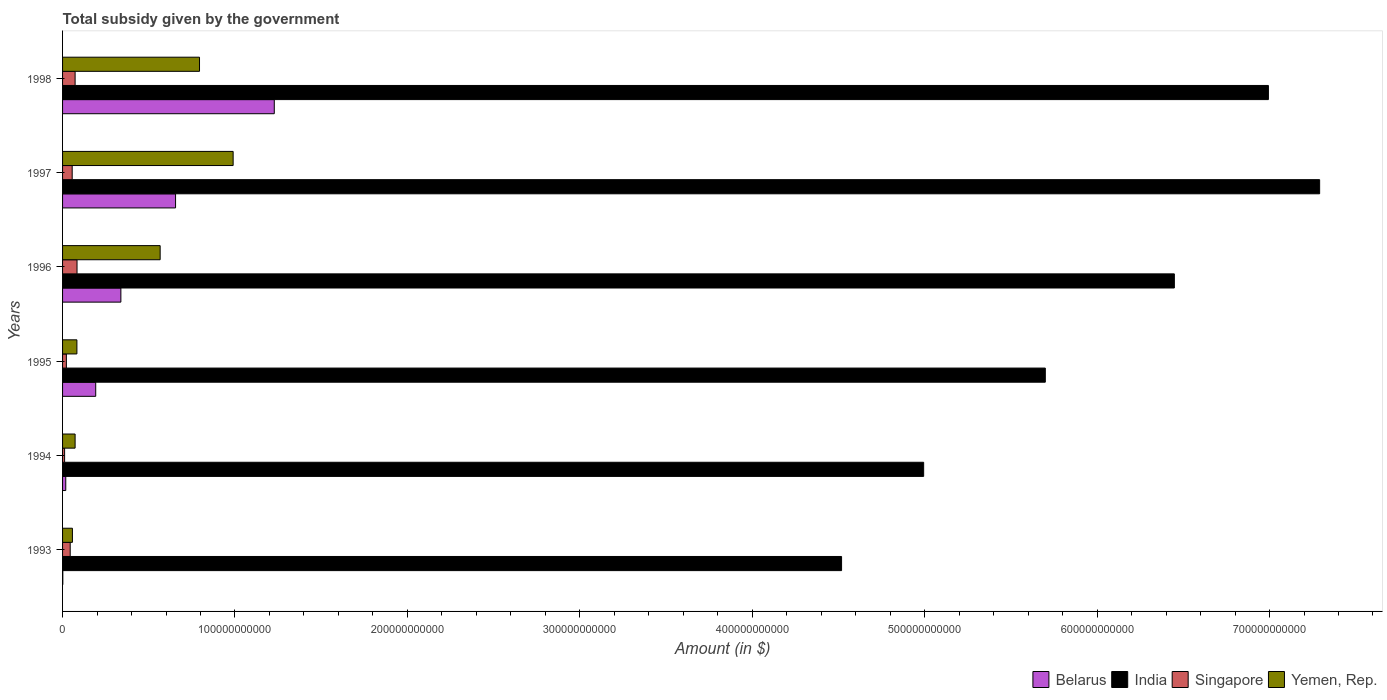How many different coloured bars are there?
Your response must be concise. 4. How many groups of bars are there?
Offer a terse response. 6. Are the number of bars on each tick of the Y-axis equal?
Make the answer very short. Yes. How many bars are there on the 5th tick from the bottom?
Keep it short and to the point. 4. What is the label of the 3rd group of bars from the top?
Provide a succinct answer. 1996. In how many cases, is the number of bars for a given year not equal to the number of legend labels?
Provide a short and direct response. 0. What is the total revenue collected by the government in India in 1994?
Keep it short and to the point. 4.99e+11. Across all years, what is the maximum total revenue collected by the government in Singapore?
Offer a terse response. 8.39e+09. Across all years, what is the minimum total revenue collected by the government in Belarus?
Offer a very short reply. 1.42e+08. In which year was the total revenue collected by the government in Yemen, Rep. maximum?
Provide a succinct answer. 1997. What is the total total revenue collected by the government in Belarus in the graph?
Provide a succinct answer. 2.43e+11. What is the difference between the total revenue collected by the government in Belarus in 1993 and that in 1995?
Your answer should be compact. -1.91e+1. What is the difference between the total revenue collected by the government in Belarus in 1996 and the total revenue collected by the government in India in 1997?
Make the answer very short. -6.95e+11. What is the average total revenue collected by the government in India per year?
Your answer should be very brief. 5.99e+11. In the year 1993, what is the difference between the total revenue collected by the government in India and total revenue collected by the government in Belarus?
Your response must be concise. 4.52e+11. What is the ratio of the total revenue collected by the government in Yemen, Rep. in 1993 to that in 1996?
Ensure brevity in your answer.  0.1. Is the total revenue collected by the government in Belarus in 1993 less than that in 1996?
Keep it short and to the point. Yes. What is the difference between the highest and the second highest total revenue collected by the government in Belarus?
Ensure brevity in your answer.  5.73e+1. What is the difference between the highest and the lowest total revenue collected by the government in Singapore?
Provide a succinct answer. 7.20e+09. In how many years, is the total revenue collected by the government in Belarus greater than the average total revenue collected by the government in Belarus taken over all years?
Your answer should be very brief. 2. Is the sum of the total revenue collected by the government in Belarus in 1994 and 1998 greater than the maximum total revenue collected by the government in Yemen, Rep. across all years?
Your answer should be very brief. Yes. Is it the case that in every year, the sum of the total revenue collected by the government in Singapore and total revenue collected by the government in India is greater than the sum of total revenue collected by the government in Yemen, Rep. and total revenue collected by the government in Belarus?
Your response must be concise. Yes. What does the 1st bar from the top in 1995 represents?
Your answer should be very brief. Yemen, Rep. What does the 1st bar from the bottom in 1995 represents?
Provide a succinct answer. Belarus. Is it the case that in every year, the sum of the total revenue collected by the government in Singapore and total revenue collected by the government in Yemen, Rep. is greater than the total revenue collected by the government in India?
Make the answer very short. No. How many bars are there?
Provide a short and direct response. 24. What is the difference between two consecutive major ticks on the X-axis?
Provide a succinct answer. 1.00e+11. How many legend labels are there?
Provide a short and direct response. 4. How are the legend labels stacked?
Offer a very short reply. Horizontal. What is the title of the graph?
Ensure brevity in your answer.  Total subsidy given by the government. What is the label or title of the X-axis?
Your response must be concise. Amount (in $). What is the Amount (in $) in Belarus in 1993?
Make the answer very short. 1.42e+08. What is the Amount (in $) in India in 1993?
Provide a short and direct response. 4.52e+11. What is the Amount (in $) in Singapore in 1993?
Your answer should be compact. 4.43e+09. What is the Amount (in $) of Yemen, Rep. in 1993?
Provide a short and direct response. 5.71e+09. What is the Amount (in $) in Belarus in 1994?
Make the answer very short. 1.86e+09. What is the Amount (in $) in India in 1994?
Your answer should be compact. 4.99e+11. What is the Amount (in $) in Singapore in 1994?
Your answer should be very brief. 1.19e+09. What is the Amount (in $) of Yemen, Rep. in 1994?
Your answer should be compact. 7.27e+09. What is the Amount (in $) in Belarus in 1995?
Keep it short and to the point. 1.92e+1. What is the Amount (in $) of India in 1995?
Make the answer very short. 5.70e+11. What is the Amount (in $) in Singapore in 1995?
Ensure brevity in your answer.  2.21e+09. What is the Amount (in $) in Yemen, Rep. in 1995?
Offer a very short reply. 8.32e+09. What is the Amount (in $) in Belarus in 1996?
Offer a very short reply. 3.38e+1. What is the Amount (in $) of India in 1996?
Offer a terse response. 6.45e+11. What is the Amount (in $) of Singapore in 1996?
Your answer should be very brief. 8.39e+09. What is the Amount (in $) of Yemen, Rep. in 1996?
Offer a very short reply. 5.66e+1. What is the Amount (in $) of Belarus in 1997?
Keep it short and to the point. 6.55e+1. What is the Amount (in $) in India in 1997?
Make the answer very short. 7.29e+11. What is the Amount (in $) of Singapore in 1997?
Give a very brief answer. 5.58e+09. What is the Amount (in $) of Yemen, Rep. in 1997?
Give a very brief answer. 9.89e+1. What is the Amount (in $) of Belarus in 1998?
Your answer should be compact. 1.23e+11. What is the Amount (in $) of India in 1998?
Make the answer very short. 6.99e+11. What is the Amount (in $) in Singapore in 1998?
Your answer should be very brief. 7.28e+09. What is the Amount (in $) of Yemen, Rep. in 1998?
Offer a terse response. 7.94e+1. Across all years, what is the maximum Amount (in $) of Belarus?
Offer a very short reply. 1.23e+11. Across all years, what is the maximum Amount (in $) of India?
Your response must be concise. 7.29e+11. Across all years, what is the maximum Amount (in $) of Singapore?
Keep it short and to the point. 8.39e+09. Across all years, what is the maximum Amount (in $) in Yemen, Rep.?
Offer a terse response. 9.89e+1. Across all years, what is the minimum Amount (in $) in Belarus?
Your answer should be very brief. 1.42e+08. Across all years, what is the minimum Amount (in $) of India?
Provide a short and direct response. 4.52e+11. Across all years, what is the minimum Amount (in $) of Singapore?
Provide a short and direct response. 1.19e+09. Across all years, what is the minimum Amount (in $) in Yemen, Rep.?
Provide a succinct answer. 5.71e+09. What is the total Amount (in $) of Belarus in the graph?
Your answer should be compact. 2.43e+11. What is the total Amount (in $) in India in the graph?
Your response must be concise. 3.59e+12. What is the total Amount (in $) in Singapore in the graph?
Provide a succinct answer. 2.91e+1. What is the total Amount (in $) in Yemen, Rep. in the graph?
Your response must be concise. 2.56e+11. What is the difference between the Amount (in $) in Belarus in 1993 and that in 1994?
Give a very brief answer. -1.72e+09. What is the difference between the Amount (in $) of India in 1993 and that in 1994?
Your answer should be very brief. -4.76e+1. What is the difference between the Amount (in $) in Singapore in 1993 and that in 1994?
Offer a terse response. 3.24e+09. What is the difference between the Amount (in $) of Yemen, Rep. in 1993 and that in 1994?
Give a very brief answer. -1.56e+09. What is the difference between the Amount (in $) in Belarus in 1993 and that in 1995?
Your response must be concise. -1.91e+1. What is the difference between the Amount (in $) of India in 1993 and that in 1995?
Ensure brevity in your answer.  -1.18e+11. What is the difference between the Amount (in $) of Singapore in 1993 and that in 1995?
Offer a very short reply. 2.22e+09. What is the difference between the Amount (in $) in Yemen, Rep. in 1993 and that in 1995?
Provide a short and direct response. -2.60e+09. What is the difference between the Amount (in $) in Belarus in 1993 and that in 1996?
Ensure brevity in your answer.  -3.37e+1. What is the difference between the Amount (in $) in India in 1993 and that in 1996?
Your answer should be compact. -1.93e+11. What is the difference between the Amount (in $) in Singapore in 1993 and that in 1996?
Ensure brevity in your answer.  -3.95e+09. What is the difference between the Amount (in $) in Yemen, Rep. in 1993 and that in 1996?
Provide a succinct answer. -5.09e+1. What is the difference between the Amount (in $) in Belarus in 1993 and that in 1997?
Ensure brevity in your answer.  -6.54e+1. What is the difference between the Amount (in $) in India in 1993 and that in 1997?
Your answer should be very brief. -2.77e+11. What is the difference between the Amount (in $) in Singapore in 1993 and that in 1997?
Make the answer very short. -1.15e+09. What is the difference between the Amount (in $) in Yemen, Rep. in 1993 and that in 1997?
Make the answer very short. -9.32e+1. What is the difference between the Amount (in $) in Belarus in 1993 and that in 1998?
Provide a short and direct response. -1.23e+11. What is the difference between the Amount (in $) of India in 1993 and that in 1998?
Your answer should be compact. -2.48e+11. What is the difference between the Amount (in $) in Singapore in 1993 and that in 1998?
Offer a very short reply. -2.84e+09. What is the difference between the Amount (in $) of Yemen, Rep. in 1993 and that in 1998?
Ensure brevity in your answer.  -7.37e+1. What is the difference between the Amount (in $) in Belarus in 1994 and that in 1995?
Your answer should be very brief. -1.74e+1. What is the difference between the Amount (in $) of India in 1994 and that in 1995?
Your answer should be compact. -7.06e+1. What is the difference between the Amount (in $) in Singapore in 1994 and that in 1995?
Your answer should be compact. -1.02e+09. What is the difference between the Amount (in $) in Yemen, Rep. in 1994 and that in 1995?
Provide a short and direct response. -1.04e+09. What is the difference between the Amount (in $) in Belarus in 1994 and that in 1996?
Make the answer very short. -3.20e+1. What is the difference between the Amount (in $) of India in 1994 and that in 1996?
Your answer should be compact. -1.45e+11. What is the difference between the Amount (in $) of Singapore in 1994 and that in 1996?
Offer a very short reply. -7.20e+09. What is the difference between the Amount (in $) in Yemen, Rep. in 1994 and that in 1996?
Provide a succinct answer. -4.93e+1. What is the difference between the Amount (in $) in Belarus in 1994 and that in 1997?
Your response must be concise. -6.37e+1. What is the difference between the Amount (in $) in India in 1994 and that in 1997?
Keep it short and to the point. -2.30e+11. What is the difference between the Amount (in $) of Singapore in 1994 and that in 1997?
Provide a short and direct response. -4.39e+09. What is the difference between the Amount (in $) in Yemen, Rep. in 1994 and that in 1997?
Make the answer very short. -9.17e+1. What is the difference between the Amount (in $) in Belarus in 1994 and that in 1998?
Provide a succinct answer. -1.21e+11. What is the difference between the Amount (in $) of India in 1994 and that in 1998?
Provide a succinct answer. -2.00e+11. What is the difference between the Amount (in $) of Singapore in 1994 and that in 1998?
Give a very brief answer. -6.09e+09. What is the difference between the Amount (in $) in Yemen, Rep. in 1994 and that in 1998?
Your answer should be compact. -7.22e+1. What is the difference between the Amount (in $) of Belarus in 1995 and that in 1996?
Make the answer very short. -1.46e+1. What is the difference between the Amount (in $) in India in 1995 and that in 1996?
Your answer should be compact. -7.48e+1. What is the difference between the Amount (in $) of Singapore in 1995 and that in 1996?
Give a very brief answer. -6.18e+09. What is the difference between the Amount (in $) in Yemen, Rep. in 1995 and that in 1996?
Offer a very short reply. -4.83e+1. What is the difference between the Amount (in $) in Belarus in 1995 and that in 1997?
Keep it short and to the point. -4.63e+1. What is the difference between the Amount (in $) in India in 1995 and that in 1997?
Make the answer very short. -1.59e+11. What is the difference between the Amount (in $) in Singapore in 1995 and that in 1997?
Provide a short and direct response. -3.37e+09. What is the difference between the Amount (in $) in Yemen, Rep. in 1995 and that in 1997?
Offer a very short reply. -9.06e+1. What is the difference between the Amount (in $) in Belarus in 1995 and that in 1998?
Make the answer very short. -1.04e+11. What is the difference between the Amount (in $) of India in 1995 and that in 1998?
Make the answer very short. -1.29e+11. What is the difference between the Amount (in $) of Singapore in 1995 and that in 1998?
Provide a succinct answer. -5.07e+09. What is the difference between the Amount (in $) in Yemen, Rep. in 1995 and that in 1998?
Keep it short and to the point. -7.11e+1. What is the difference between the Amount (in $) of Belarus in 1996 and that in 1997?
Provide a succinct answer. -3.17e+1. What is the difference between the Amount (in $) of India in 1996 and that in 1997?
Your answer should be very brief. -8.43e+1. What is the difference between the Amount (in $) of Singapore in 1996 and that in 1997?
Offer a very short reply. 2.80e+09. What is the difference between the Amount (in $) of Yemen, Rep. in 1996 and that in 1997?
Ensure brevity in your answer.  -4.23e+1. What is the difference between the Amount (in $) in Belarus in 1996 and that in 1998?
Provide a short and direct response. -8.90e+1. What is the difference between the Amount (in $) in India in 1996 and that in 1998?
Provide a short and direct response. -5.46e+1. What is the difference between the Amount (in $) in Singapore in 1996 and that in 1998?
Offer a terse response. 1.11e+09. What is the difference between the Amount (in $) of Yemen, Rep. in 1996 and that in 1998?
Offer a very short reply. -2.28e+1. What is the difference between the Amount (in $) in Belarus in 1997 and that in 1998?
Make the answer very short. -5.73e+1. What is the difference between the Amount (in $) of India in 1997 and that in 1998?
Give a very brief answer. 2.97e+1. What is the difference between the Amount (in $) of Singapore in 1997 and that in 1998?
Make the answer very short. -1.70e+09. What is the difference between the Amount (in $) of Yemen, Rep. in 1997 and that in 1998?
Give a very brief answer. 1.95e+1. What is the difference between the Amount (in $) in Belarus in 1993 and the Amount (in $) in India in 1994?
Your response must be concise. -4.99e+11. What is the difference between the Amount (in $) of Belarus in 1993 and the Amount (in $) of Singapore in 1994?
Make the answer very short. -1.05e+09. What is the difference between the Amount (in $) of Belarus in 1993 and the Amount (in $) of Yemen, Rep. in 1994?
Offer a very short reply. -7.13e+09. What is the difference between the Amount (in $) of India in 1993 and the Amount (in $) of Singapore in 1994?
Your answer should be very brief. 4.51e+11. What is the difference between the Amount (in $) in India in 1993 and the Amount (in $) in Yemen, Rep. in 1994?
Give a very brief answer. 4.45e+11. What is the difference between the Amount (in $) of Singapore in 1993 and the Amount (in $) of Yemen, Rep. in 1994?
Provide a succinct answer. -2.84e+09. What is the difference between the Amount (in $) of Belarus in 1993 and the Amount (in $) of India in 1995?
Offer a very short reply. -5.70e+11. What is the difference between the Amount (in $) in Belarus in 1993 and the Amount (in $) in Singapore in 1995?
Your answer should be very brief. -2.07e+09. What is the difference between the Amount (in $) of Belarus in 1993 and the Amount (in $) of Yemen, Rep. in 1995?
Offer a terse response. -8.17e+09. What is the difference between the Amount (in $) in India in 1993 and the Amount (in $) in Singapore in 1995?
Your answer should be compact. 4.50e+11. What is the difference between the Amount (in $) of India in 1993 and the Amount (in $) of Yemen, Rep. in 1995?
Offer a very short reply. 4.43e+11. What is the difference between the Amount (in $) of Singapore in 1993 and the Amount (in $) of Yemen, Rep. in 1995?
Ensure brevity in your answer.  -3.88e+09. What is the difference between the Amount (in $) in Belarus in 1993 and the Amount (in $) in India in 1996?
Keep it short and to the point. -6.45e+11. What is the difference between the Amount (in $) in Belarus in 1993 and the Amount (in $) in Singapore in 1996?
Your response must be concise. -8.24e+09. What is the difference between the Amount (in $) in Belarus in 1993 and the Amount (in $) in Yemen, Rep. in 1996?
Provide a short and direct response. -5.65e+1. What is the difference between the Amount (in $) in India in 1993 and the Amount (in $) in Singapore in 1996?
Keep it short and to the point. 4.43e+11. What is the difference between the Amount (in $) in India in 1993 and the Amount (in $) in Yemen, Rep. in 1996?
Provide a short and direct response. 3.95e+11. What is the difference between the Amount (in $) in Singapore in 1993 and the Amount (in $) in Yemen, Rep. in 1996?
Offer a very short reply. -5.22e+1. What is the difference between the Amount (in $) of Belarus in 1993 and the Amount (in $) of India in 1997?
Your answer should be compact. -7.29e+11. What is the difference between the Amount (in $) of Belarus in 1993 and the Amount (in $) of Singapore in 1997?
Provide a succinct answer. -5.44e+09. What is the difference between the Amount (in $) of Belarus in 1993 and the Amount (in $) of Yemen, Rep. in 1997?
Give a very brief answer. -9.88e+1. What is the difference between the Amount (in $) of India in 1993 and the Amount (in $) of Singapore in 1997?
Make the answer very short. 4.46e+11. What is the difference between the Amount (in $) of India in 1993 and the Amount (in $) of Yemen, Rep. in 1997?
Your answer should be very brief. 3.53e+11. What is the difference between the Amount (in $) of Singapore in 1993 and the Amount (in $) of Yemen, Rep. in 1997?
Give a very brief answer. -9.45e+1. What is the difference between the Amount (in $) in Belarus in 1993 and the Amount (in $) in India in 1998?
Offer a terse response. -6.99e+11. What is the difference between the Amount (in $) in Belarus in 1993 and the Amount (in $) in Singapore in 1998?
Your response must be concise. -7.14e+09. What is the difference between the Amount (in $) in Belarus in 1993 and the Amount (in $) in Yemen, Rep. in 1998?
Make the answer very short. -7.93e+1. What is the difference between the Amount (in $) of India in 1993 and the Amount (in $) of Singapore in 1998?
Make the answer very short. 4.45e+11. What is the difference between the Amount (in $) in India in 1993 and the Amount (in $) in Yemen, Rep. in 1998?
Make the answer very short. 3.72e+11. What is the difference between the Amount (in $) in Singapore in 1993 and the Amount (in $) in Yemen, Rep. in 1998?
Provide a succinct answer. -7.50e+1. What is the difference between the Amount (in $) in Belarus in 1994 and the Amount (in $) in India in 1995?
Keep it short and to the point. -5.68e+11. What is the difference between the Amount (in $) of Belarus in 1994 and the Amount (in $) of Singapore in 1995?
Your answer should be very brief. -3.52e+08. What is the difference between the Amount (in $) of Belarus in 1994 and the Amount (in $) of Yemen, Rep. in 1995?
Provide a succinct answer. -6.46e+09. What is the difference between the Amount (in $) in India in 1994 and the Amount (in $) in Singapore in 1995?
Provide a short and direct response. 4.97e+11. What is the difference between the Amount (in $) of India in 1994 and the Amount (in $) of Yemen, Rep. in 1995?
Your answer should be compact. 4.91e+11. What is the difference between the Amount (in $) of Singapore in 1994 and the Amount (in $) of Yemen, Rep. in 1995?
Your answer should be very brief. -7.13e+09. What is the difference between the Amount (in $) in Belarus in 1994 and the Amount (in $) in India in 1996?
Give a very brief answer. -6.43e+11. What is the difference between the Amount (in $) of Belarus in 1994 and the Amount (in $) of Singapore in 1996?
Offer a terse response. -6.53e+09. What is the difference between the Amount (in $) in Belarus in 1994 and the Amount (in $) in Yemen, Rep. in 1996?
Your answer should be compact. -5.47e+1. What is the difference between the Amount (in $) of India in 1994 and the Amount (in $) of Singapore in 1996?
Your response must be concise. 4.91e+11. What is the difference between the Amount (in $) in India in 1994 and the Amount (in $) in Yemen, Rep. in 1996?
Offer a very short reply. 4.43e+11. What is the difference between the Amount (in $) of Singapore in 1994 and the Amount (in $) of Yemen, Rep. in 1996?
Give a very brief answer. -5.54e+1. What is the difference between the Amount (in $) of Belarus in 1994 and the Amount (in $) of India in 1997?
Give a very brief answer. -7.27e+11. What is the difference between the Amount (in $) of Belarus in 1994 and the Amount (in $) of Singapore in 1997?
Give a very brief answer. -3.72e+09. What is the difference between the Amount (in $) of Belarus in 1994 and the Amount (in $) of Yemen, Rep. in 1997?
Provide a succinct answer. -9.71e+1. What is the difference between the Amount (in $) of India in 1994 and the Amount (in $) of Singapore in 1997?
Offer a very short reply. 4.94e+11. What is the difference between the Amount (in $) in India in 1994 and the Amount (in $) in Yemen, Rep. in 1997?
Offer a terse response. 4.00e+11. What is the difference between the Amount (in $) of Singapore in 1994 and the Amount (in $) of Yemen, Rep. in 1997?
Keep it short and to the point. -9.77e+1. What is the difference between the Amount (in $) of Belarus in 1994 and the Amount (in $) of India in 1998?
Offer a very short reply. -6.97e+11. What is the difference between the Amount (in $) in Belarus in 1994 and the Amount (in $) in Singapore in 1998?
Keep it short and to the point. -5.42e+09. What is the difference between the Amount (in $) in Belarus in 1994 and the Amount (in $) in Yemen, Rep. in 1998?
Provide a succinct answer. -7.76e+1. What is the difference between the Amount (in $) in India in 1994 and the Amount (in $) in Singapore in 1998?
Make the answer very short. 4.92e+11. What is the difference between the Amount (in $) of India in 1994 and the Amount (in $) of Yemen, Rep. in 1998?
Give a very brief answer. 4.20e+11. What is the difference between the Amount (in $) of Singapore in 1994 and the Amount (in $) of Yemen, Rep. in 1998?
Keep it short and to the point. -7.82e+1. What is the difference between the Amount (in $) of Belarus in 1995 and the Amount (in $) of India in 1996?
Your response must be concise. -6.26e+11. What is the difference between the Amount (in $) in Belarus in 1995 and the Amount (in $) in Singapore in 1996?
Offer a very short reply. 1.08e+1. What is the difference between the Amount (in $) of Belarus in 1995 and the Amount (in $) of Yemen, Rep. in 1996?
Ensure brevity in your answer.  -3.74e+1. What is the difference between the Amount (in $) of India in 1995 and the Amount (in $) of Singapore in 1996?
Provide a succinct answer. 5.62e+11. What is the difference between the Amount (in $) of India in 1995 and the Amount (in $) of Yemen, Rep. in 1996?
Give a very brief answer. 5.13e+11. What is the difference between the Amount (in $) of Singapore in 1995 and the Amount (in $) of Yemen, Rep. in 1996?
Offer a terse response. -5.44e+1. What is the difference between the Amount (in $) of Belarus in 1995 and the Amount (in $) of India in 1997?
Provide a short and direct response. -7.10e+11. What is the difference between the Amount (in $) in Belarus in 1995 and the Amount (in $) in Singapore in 1997?
Make the answer very short. 1.36e+1. What is the difference between the Amount (in $) in Belarus in 1995 and the Amount (in $) in Yemen, Rep. in 1997?
Keep it short and to the point. -7.97e+1. What is the difference between the Amount (in $) in India in 1995 and the Amount (in $) in Singapore in 1997?
Give a very brief answer. 5.64e+11. What is the difference between the Amount (in $) of India in 1995 and the Amount (in $) of Yemen, Rep. in 1997?
Keep it short and to the point. 4.71e+11. What is the difference between the Amount (in $) of Singapore in 1995 and the Amount (in $) of Yemen, Rep. in 1997?
Your answer should be very brief. -9.67e+1. What is the difference between the Amount (in $) in Belarus in 1995 and the Amount (in $) in India in 1998?
Your response must be concise. -6.80e+11. What is the difference between the Amount (in $) in Belarus in 1995 and the Amount (in $) in Singapore in 1998?
Provide a succinct answer. 1.19e+1. What is the difference between the Amount (in $) in Belarus in 1995 and the Amount (in $) in Yemen, Rep. in 1998?
Provide a succinct answer. -6.02e+1. What is the difference between the Amount (in $) in India in 1995 and the Amount (in $) in Singapore in 1998?
Your answer should be very brief. 5.63e+11. What is the difference between the Amount (in $) of India in 1995 and the Amount (in $) of Yemen, Rep. in 1998?
Keep it short and to the point. 4.91e+11. What is the difference between the Amount (in $) of Singapore in 1995 and the Amount (in $) of Yemen, Rep. in 1998?
Offer a terse response. -7.72e+1. What is the difference between the Amount (in $) of Belarus in 1996 and the Amount (in $) of India in 1997?
Provide a succinct answer. -6.95e+11. What is the difference between the Amount (in $) in Belarus in 1996 and the Amount (in $) in Singapore in 1997?
Give a very brief answer. 2.82e+1. What is the difference between the Amount (in $) of Belarus in 1996 and the Amount (in $) of Yemen, Rep. in 1997?
Your answer should be very brief. -6.51e+1. What is the difference between the Amount (in $) in India in 1996 and the Amount (in $) in Singapore in 1997?
Your answer should be very brief. 6.39e+11. What is the difference between the Amount (in $) of India in 1996 and the Amount (in $) of Yemen, Rep. in 1997?
Ensure brevity in your answer.  5.46e+11. What is the difference between the Amount (in $) in Singapore in 1996 and the Amount (in $) in Yemen, Rep. in 1997?
Ensure brevity in your answer.  -9.05e+1. What is the difference between the Amount (in $) of Belarus in 1996 and the Amount (in $) of India in 1998?
Your response must be concise. -6.66e+11. What is the difference between the Amount (in $) in Belarus in 1996 and the Amount (in $) in Singapore in 1998?
Your answer should be very brief. 2.65e+1. What is the difference between the Amount (in $) in Belarus in 1996 and the Amount (in $) in Yemen, Rep. in 1998?
Ensure brevity in your answer.  -4.56e+1. What is the difference between the Amount (in $) in India in 1996 and the Amount (in $) in Singapore in 1998?
Provide a succinct answer. 6.38e+11. What is the difference between the Amount (in $) of India in 1996 and the Amount (in $) of Yemen, Rep. in 1998?
Ensure brevity in your answer.  5.65e+11. What is the difference between the Amount (in $) of Singapore in 1996 and the Amount (in $) of Yemen, Rep. in 1998?
Offer a very short reply. -7.10e+1. What is the difference between the Amount (in $) of Belarus in 1997 and the Amount (in $) of India in 1998?
Your response must be concise. -6.34e+11. What is the difference between the Amount (in $) of Belarus in 1997 and the Amount (in $) of Singapore in 1998?
Keep it short and to the point. 5.83e+1. What is the difference between the Amount (in $) of Belarus in 1997 and the Amount (in $) of Yemen, Rep. in 1998?
Keep it short and to the point. -1.39e+1. What is the difference between the Amount (in $) in India in 1997 and the Amount (in $) in Singapore in 1998?
Keep it short and to the point. 7.22e+11. What is the difference between the Amount (in $) in India in 1997 and the Amount (in $) in Yemen, Rep. in 1998?
Your answer should be very brief. 6.50e+11. What is the difference between the Amount (in $) in Singapore in 1997 and the Amount (in $) in Yemen, Rep. in 1998?
Offer a terse response. -7.38e+1. What is the average Amount (in $) of Belarus per year?
Provide a short and direct response. 4.06e+1. What is the average Amount (in $) in India per year?
Your answer should be very brief. 5.99e+11. What is the average Amount (in $) in Singapore per year?
Ensure brevity in your answer.  4.85e+09. What is the average Amount (in $) of Yemen, Rep. per year?
Your answer should be very brief. 4.27e+1. In the year 1993, what is the difference between the Amount (in $) in Belarus and Amount (in $) in India?
Provide a short and direct response. -4.52e+11. In the year 1993, what is the difference between the Amount (in $) in Belarus and Amount (in $) in Singapore?
Keep it short and to the point. -4.29e+09. In the year 1993, what is the difference between the Amount (in $) in Belarus and Amount (in $) in Yemen, Rep.?
Offer a very short reply. -5.57e+09. In the year 1993, what is the difference between the Amount (in $) of India and Amount (in $) of Singapore?
Provide a succinct answer. 4.47e+11. In the year 1993, what is the difference between the Amount (in $) in India and Amount (in $) in Yemen, Rep.?
Your response must be concise. 4.46e+11. In the year 1993, what is the difference between the Amount (in $) in Singapore and Amount (in $) in Yemen, Rep.?
Offer a terse response. -1.28e+09. In the year 1994, what is the difference between the Amount (in $) of Belarus and Amount (in $) of India?
Ensure brevity in your answer.  -4.98e+11. In the year 1994, what is the difference between the Amount (in $) in Belarus and Amount (in $) in Singapore?
Your answer should be very brief. 6.68e+08. In the year 1994, what is the difference between the Amount (in $) of Belarus and Amount (in $) of Yemen, Rep.?
Provide a short and direct response. -5.42e+09. In the year 1994, what is the difference between the Amount (in $) of India and Amount (in $) of Singapore?
Your answer should be compact. 4.98e+11. In the year 1994, what is the difference between the Amount (in $) of India and Amount (in $) of Yemen, Rep.?
Offer a very short reply. 4.92e+11. In the year 1994, what is the difference between the Amount (in $) in Singapore and Amount (in $) in Yemen, Rep.?
Your answer should be very brief. -6.09e+09. In the year 1995, what is the difference between the Amount (in $) of Belarus and Amount (in $) of India?
Give a very brief answer. -5.51e+11. In the year 1995, what is the difference between the Amount (in $) of Belarus and Amount (in $) of Singapore?
Your answer should be very brief. 1.70e+1. In the year 1995, what is the difference between the Amount (in $) of Belarus and Amount (in $) of Yemen, Rep.?
Make the answer very short. 1.09e+1. In the year 1995, what is the difference between the Amount (in $) of India and Amount (in $) of Singapore?
Provide a succinct answer. 5.68e+11. In the year 1995, what is the difference between the Amount (in $) in India and Amount (in $) in Yemen, Rep.?
Offer a terse response. 5.62e+11. In the year 1995, what is the difference between the Amount (in $) of Singapore and Amount (in $) of Yemen, Rep.?
Provide a short and direct response. -6.11e+09. In the year 1996, what is the difference between the Amount (in $) of Belarus and Amount (in $) of India?
Offer a terse response. -6.11e+11. In the year 1996, what is the difference between the Amount (in $) of Belarus and Amount (in $) of Singapore?
Your response must be concise. 2.54e+1. In the year 1996, what is the difference between the Amount (in $) of Belarus and Amount (in $) of Yemen, Rep.?
Make the answer very short. -2.28e+1. In the year 1996, what is the difference between the Amount (in $) in India and Amount (in $) in Singapore?
Make the answer very short. 6.36e+11. In the year 1996, what is the difference between the Amount (in $) of India and Amount (in $) of Yemen, Rep.?
Ensure brevity in your answer.  5.88e+11. In the year 1996, what is the difference between the Amount (in $) of Singapore and Amount (in $) of Yemen, Rep.?
Provide a short and direct response. -4.82e+1. In the year 1997, what is the difference between the Amount (in $) of Belarus and Amount (in $) of India?
Give a very brief answer. -6.64e+11. In the year 1997, what is the difference between the Amount (in $) of Belarus and Amount (in $) of Singapore?
Your answer should be compact. 6.00e+1. In the year 1997, what is the difference between the Amount (in $) in Belarus and Amount (in $) in Yemen, Rep.?
Ensure brevity in your answer.  -3.34e+1. In the year 1997, what is the difference between the Amount (in $) in India and Amount (in $) in Singapore?
Ensure brevity in your answer.  7.23e+11. In the year 1997, what is the difference between the Amount (in $) of India and Amount (in $) of Yemen, Rep.?
Give a very brief answer. 6.30e+11. In the year 1997, what is the difference between the Amount (in $) in Singapore and Amount (in $) in Yemen, Rep.?
Make the answer very short. -9.33e+1. In the year 1998, what is the difference between the Amount (in $) in Belarus and Amount (in $) in India?
Make the answer very short. -5.77e+11. In the year 1998, what is the difference between the Amount (in $) of Belarus and Amount (in $) of Singapore?
Your answer should be compact. 1.16e+11. In the year 1998, what is the difference between the Amount (in $) of Belarus and Amount (in $) of Yemen, Rep.?
Offer a terse response. 4.34e+1. In the year 1998, what is the difference between the Amount (in $) in India and Amount (in $) in Singapore?
Provide a succinct answer. 6.92e+11. In the year 1998, what is the difference between the Amount (in $) of India and Amount (in $) of Yemen, Rep.?
Ensure brevity in your answer.  6.20e+11. In the year 1998, what is the difference between the Amount (in $) in Singapore and Amount (in $) in Yemen, Rep.?
Offer a terse response. -7.22e+1. What is the ratio of the Amount (in $) in Belarus in 1993 to that in 1994?
Ensure brevity in your answer.  0.08. What is the ratio of the Amount (in $) of India in 1993 to that in 1994?
Give a very brief answer. 0.9. What is the ratio of the Amount (in $) of Singapore in 1993 to that in 1994?
Provide a short and direct response. 3.73. What is the ratio of the Amount (in $) in Yemen, Rep. in 1993 to that in 1994?
Your answer should be very brief. 0.79. What is the ratio of the Amount (in $) of Belarus in 1993 to that in 1995?
Keep it short and to the point. 0.01. What is the ratio of the Amount (in $) in India in 1993 to that in 1995?
Your answer should be compact. 0.79. What is the ratio of the Amount (in $) in Singapore in 1993 to that in 1995?
Provide a succinct answer. 2.01. What is the ratio of the Amount (in $) of Yemen, Rep. in 1993 to that in 1995?
Make the answer very short. 0.69. What is the ratio of the Amount (in $) in Belarus in 1993 to that in 1996?
Your answer should be very brief. 0. What is the ratio of the Amount (in $) in India in 1993 to that in 1996?
Give a very brief answer. 0.7. What is the ratio of the Amount (in $) in Singapore in 1993 to that in 1996?
Your response must be concise. 0.53. What is the ratio of the Amount (in $) of Yemen, Rep. in 1993 to that in 1996?
Offer a terse response. 0.1. What is the ratio of the Amount (in $) in Belarus in 1993 to that in 1997?
Provide a succinct answer. 0. What is the ratio of the Amount (in $) in India in 1993 to that in 1997?
Your answer should be very brief. 0.62. What is the ratio of the Amount (in $) of Singapore in 1993 to that in 1997?
Keep it short and to the point. 0.79. What is the ratio of the Amount (in $) in Yemen, Rep. in 1993 to that in 1997?
Make the answer very short. 0.06. What is the ratio of the Amount (in $) of Belarus in 1993 to that in 1998?
Your answer should be very brief. 0. What is the ratio of the Amount (in $) of India in 1993 to that in 1998?
Provide a succinct answer. 0.65. What is the ratio of the Amount (in $) of Singapore in 1993 to that in 1998?
Your response must be concise. 0.61. What is the ratio of the Amount (in $) in Yemen, Rep. in 1993 to that in 1998?
Ensure brevity in your answer.  0.07. What is the ratio of the Amount (in $) in Belarus in 1994 to that in 1995?
Provide a short and direct response. 0.1. What is the ratio of the Amount (in $) in India in 1994 to that in 1995?
Your answer should be very brief. 0.88. What is the ratio of the Amount (in $) of Singapore in 1994 to that in 1995?
Your answer should be very brief. 0.54. What is the ratio of the Amount (in $) in Yemen, Rep. in 1994 to that in 1995?
Ensure brevity in your answer.  0.87. What is the ratio of the Amount (in $) in Belarus in 1994 to that in 1996?
Offer a terse response. 0.05. What is the ratio of the Amount (in $) of India in 1994 to that in 1996?
Your answer should be compact. 0.77. What is the ratio of the Amount (in $) in Singapore in 1994 to that in 1996?
Offer a terse response. 0.14. What is the ratio of the Amount (in $) in Yemen, Rep. in 1994 to that in 1996?
Give a very brief answer. 0.13. What is the ratio of the Amount (in $) in Belarus in 1994 to that in 1997?
Provide a short and direct response. 0.03. What is the ratio of the Amount (in $) of India in 1994 to that in 1997?
Offer a terse response. 0.69. What is the ratio of the Amount (in $) of Singapore in 1994 to that in 1997?
Your answer should be compact. 0.21. What is the ratio of the Amount (in $) in Yemen, Rep. in 1994 to that in 1997?
Offer a very short reply. 0.07. What is the ratio of the Amount (in $) in Belarus in 1994 to that in 1998?
Provide a short and direct response. 0.02. What is the ratio of the Amount (in $) of India in 1994 to that in 1998?
Your answer should be very brief. 0.71. What is the ratio of the Amount (in $) in Singapore in 1994 to that in 1998?
Offer a very short reply. 0.16. What is the ratio of the Amount (in $) of Yemen, Rep. in 1994 to that in 1998?
Provide a short and direct response. 0.09. What is the ratio of the Amount (in $) of Belarus in 1995 to that in 1996?
Provide a short and direct response. 0.57. What is the ratio of the Amount (in $) in India in 1995 to that in 1996?
Your answer should be compact. 0.88. What is the ratio of the Amount (in $) of Singapore in 1995 to that in 1996?
Make the answer very short. 0.26. What is the ratio of the Amount (in $) of Yemen, Rep. in 1995 to that in 1996?
Offer a very short reply. 0.15. What is the ratio of the Amount (in $) of Belarus in 1995 to that in 1997?
Make the answer very short. 0.29. What is the ratio of the Amount (in $) of India in 1995 to that in 1997?
Make the answer very short. 0.78. What is the ratio of the Amount (in $) of Singapore in 1995 to that in 1997?
Offer a very short reply. 0.4. What is the ratio of the Amount (in $) in Yemen, Rep. in 1995 to that in 1997?
Your response must be concise. 0.08. What is the ratio of the Amount (in $) of Belarus in 1995 to that in 1998?
Your response must be concise. 0.16. What is the ratio of the Amount (in $) in India in 1995 to that in 1998?
Make the answer very short. 0.81. What is the ratio of the Amount (in $) in Singapore in 1995 to that in 1998?
Offer a very short reply. 0.3. What is the ratio of the Amount (in $) in Yemen, Rep. in 1995 to that in 1998?
Offer a very short reply. 0.1. What is the ratio of the Amount (in $) of Belarus in 1996 to that in 1997?
Your answer should be very brief. 0.52. What is the ratio of the Amount (in $) in India in 1996 to that in 1997?
Offer a terse response. 0.88. What is the ratio of the Amount (in $) in Singapore in 1996 to that in 1997?
Give a very brief answer. 1.5. What is the ratio of the Amount (in $) of Yemen, Rep. in 1996 to that in 1997?
Ensure brevity in your answer.  0.57. What is the ratio of the Amount (in $) in Belarus in 1996 to that in 1998?
Offer a very short reply. 0.28. What is the ratio of the Amount (in $) in India in 1996 to that in 1998?
Make the answer very short. 0.92. What is the ratio of the Amount (in $) of Singapore in 1996 to that in 1998?
Your answer should be compact. 1.15. What is the ratio of the Amount (in $) in Yemen, Rep. in 1996 to that in 1998?
Your response must be concise. 0.71. What is the ratio of the Amount (in $) of Belarus in 1997 to that in 1998?
Your answer should be very brief. 0.53. What is the ratio of the Amount (in $) of India in 1997 to that in 1998?
Keep it short and to the point. 1.04. What is the ratio of the Amount (in $) of Singapore in 1997 to that in 1998?
Offer a very short reply. 0.77. What is the ratio of the Amount (in $) of Yemen, Rep. in 1997 to that in 1998?
Offer a very short reply. 1.25. What is the difference between the highest and the second highest Amount (in $) of Belarus?
Ensure brevity in your answer.  5.73e+1. What is the difference between the highest and the second highest Amount (in $) of India?
Keep it short and to the point. 2.97e+1. What is the difference between the highest and the second highest Amount (in $) in Singapore?
Make the answer very short. 1.11e+09. What is the difference between the highest and the second highest Amount (in $) of Yemen, Rep.?
Your answer should be compact. 1.95e+1. What is the difference between the highest and the lowest Amount (in $) of Belarus?
Your answer should be very brief. 1.23e+11. What is the difference between the highest and the lowest Amount (in $) in India?
Ensure brevity in your answer.  2.77e+11. What is the difference between the highest and the lowest Amount (in $) in Singapore?
Provide a short and direct response. 7.20e+09. What is the difference between the highest and the lowest Amount (in $) of Yemen, Rep.?
Make the answer very short. 9.32e+1. 